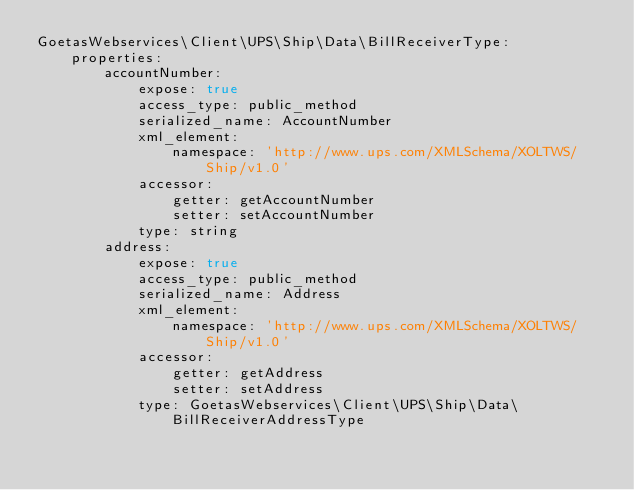Convert code to text. <code><loc_0><loc_0><loc_500><loc_500><_YAML_>GoetasWebservices\Client\UPS\Ship\Data\BillReceiverType:
    properties:
        accountNumber:
            expose: true
            access_type: public_method
            serialized_name: AccountNumber
            xml_element:
                namespace: 'http://www.ups.com/XMLSchema/XOLTWS/Ship/v1.0'
            accessor:
                getter: getAccountNumber
                setter: setAccountNumber
            type: string
        address:
            expose: true
            access_type: public_method
            serialized_name: Address
            xml_element:
                namespace: 'http://www.ups.com/XMLSchema/XOLTWS/Ship/v1.0'
            accessor:
                getter: getAddress
                setter: setAddress
            type: GoetasWebservices\Client\UPS\Ship\Data\BillReceiverAddressType
</code> 